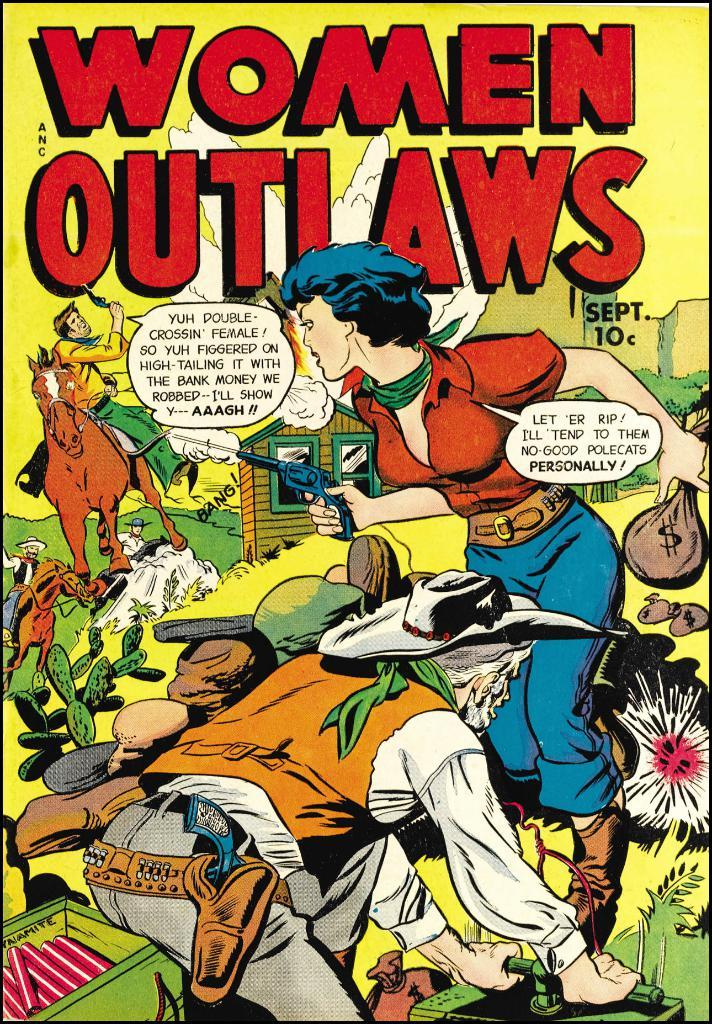<image>
Give a short and clear explanation of the subsequent image. A comic book with the title Women Outlaws. 